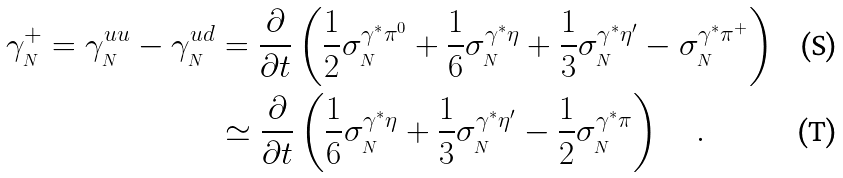<formula> <loc_0><loc_0><loc_500><loc_500>\gamma _ { _ { N } } ^ { + } = \gamma _ { _ { N } } ^ { u u } - \gamma _ { _ { N } } ^ { u d } & = \frac { \partial } { \partial t } \left ( \frac { 1 } { 2 } \sigma ^ { \gamma ^ { * } \pi ^ { 0 } } _ { _ { N } } + \frac { 1 } { 6 } \sigma ^ { \gamma ^ { * } \eta } _ { _ { N } } + \frac { 1 } { 3 } \sigma ^ { \gamma ^ { * } \eta ^ { \prime } } _ { _ { N } } - \sigma ^ { \gamma ^ { * } \pi ^ { + } } _ { _ { N } } \right ) \\ & \simeq \frac { \partial } { \partial t } \left ( \frac { 1 } { 6 } \sigma ^ { \gamma ^ { * } \eta } _ { _ { N } } + \frac { 1 } { 3 } \sigma ^ { \gamma ^ { * } \eta ^ { \prime } } _ { _ { N } } - \frac { 1 } { 2 } \sigma ^ { \gamma ^ { * } \pi } _ { _ { N } } \right ) \quad .</formula> 